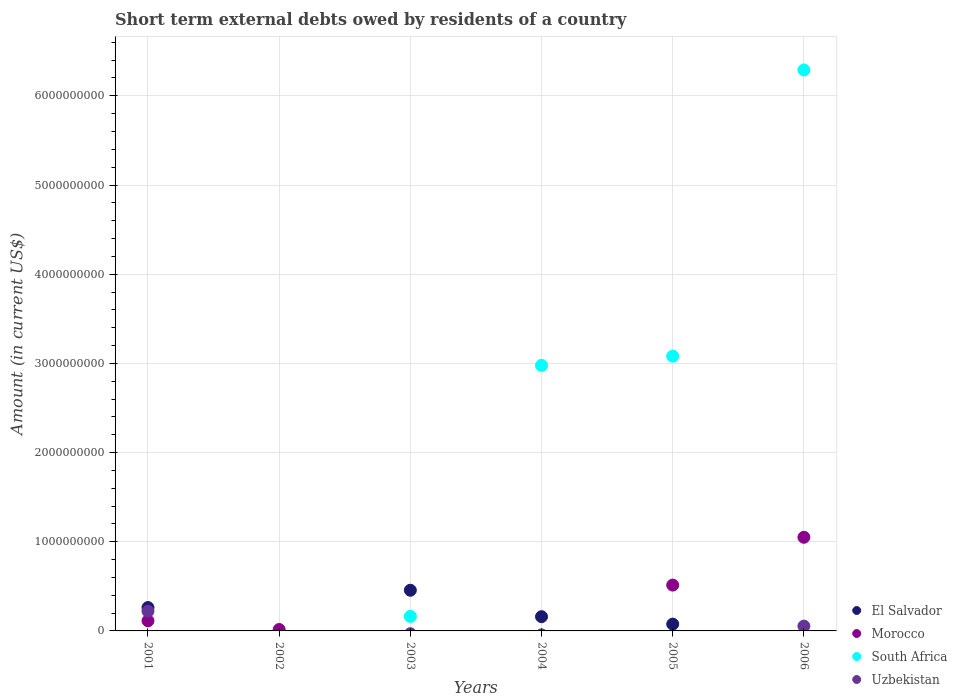How many different coloured dotlines are there?
Provide a succinct answer. 4. What is the amount of short-term external debts owed by residents in Uzbekistan in 2004?
Provide a short and direct response. 0. Across all years, what is the maximum amount of short-term external debts owed by residents in Morocco?
Keep it short and to the point. 1.05e+09. In which year was the amount of short-term external debts owed by residents in Uzbekistan maximum?
Ensure brevity in your answer.  2001. What is the total amount of short-term external debts owed by residents in Morocco in the graph?
Offer a terse response. 1.69e+09. What is the difference between the amount of short-term external debts owed by residents in Morocco in 2002 and that in 2006?
Give a very brief answer. -1.03e+09. What is the difference between the amount of short-term external debts owed by residents in Uzbekistan in 2006 and the amount of short-term external debts owed by residents in Morocco in 2004?
Ensure brevity in your answer.  5.40e+07. What is the average amount of short-term external debts owed by residents in El Salvador per year?
Give a very brief answer. 1.59e+08. In the year 2006, what is the difference between the amount of short-term external debts owed by residents in Morocco and amount of short-term external debts owed by residents in Uzbekistan?
Offer a very short reply. 9.96e+08. In how many years, is the amount of short-term external debts owed by residents in Morocco greater than 6400000000 US$?
Give a very brief answer. 0. What is the ratio of the amount of short-term external debts owed by residents in Morocco in 2002 to that in 2005?
Offer a very short reply. 0.03. Is the amount of short-term external debts owed by residents in Morocco in 2002 less than that in 2006?
Make the answer very short. Yes. What is the difference between the highest and the second highest amount of short-term external debts owed by residents in South Africa?
Give a very brief answer. 3.21e+09. What is the difference between the highest and the lowest amount of short-term external debts owed by residents in Morocco?
Give a very brief answer. 1.05e+09. In how many years, is the amount of short-term external debts owed by residents in South Africa greater than the average amount of short-term external debts owed by residents in South Africa taken over all years?
Provide a succinct answer. 3. Does the amount of short-term external debts owed by residents in El Salvador monotonically increase over the years?
Provide a short and direct response. No. Is the amount of short-term external debts owed by residents in Morocco strictly greater than the amount of short-term external debts owed by residents in El Salvador over the years?
Offer a very short reply. No. Is the amount of short-term external debts owed by residents in Uzbekistan strictly less than the amount of short-term external debts owed by residents in Morocco over the years?
Give a very brief answer. No. How many years are there in the graph?
Provide a succinct answer. 6. What is the difference between two consecutive major ticks on the Y-axis?
Offer a terse response. 1.00e+09. Does the graph contain any zero values?
Keep it short and to the point. Yes. Where does the legend appear in the graph?
Offer a terse response. Bottom right. How are the legend labels stacked?
Keep it short and to the point. Vertical. What is the title of the graph?
Your response must be concise. Short term external debts owed by residents of a country. What is the label or title of the X-axis?
Your answer should be very brief. Years. What is the Amount (in current US$) of El Salvador in 2001?
Make the answer very short. 2.62e+08. What is the Amount (in current US$) of Morocco in 2001?
Offer a terse response. 1.14e+08. What is the Amount (in current US$) of South Africa in 2001?
Give a very brief answer. 0. What is the Amount (in current US$) of Uzbekistan in 2001?
Keep it short and to the point. 2.21e+08. What is the Amount (in current US$) of Morocco in 2002?
Keep it short and to the point. 1.60e+07. What is the Amount (in current US$) in South Africa in 2002?
Ensure brevity in your answer.  0. What is the Amount (in current US$) in Uzbekistan in 2002?
Offer a very short reply. 0. What is the Amount (in current US$) of El Salvador in 2003?
Make the answer very short. 4.56e+08. What is the Amount (in current US$) of Morocco in 2003?
Your answer should be compact. 0. What is the Amount (in current US$) in South Africa in 2003?
Make the answer very short. 1.63e+08. What is the Amount (in current US$) in Uzbekistan in 2003?
Your answer should be compact. 0. What is the Amount (in current US$) of El Salvador in 2004?
Your response must be concise. 1.60e+08. What is the Amount (in current US$) of South Africa in 2004?
Your response must be concise. 2.98e+09. What is the Amount (in current US$) of Uzbekistan in 2004?
Offer a terse response. 0. What is the Amount (in current US$) in El Salvador in 2005?
Provide a succinct answer. 7.65e+07. What is the Amount (in current US$) in Morocco in 2005?
Offer a terse response. 5.14e+08. What is the Amount (in current US$) of South Africa in 2005?
Offer a very short reply. 3.08e+09. What is the Amount (in current US$) of Uzbekistan in 2005?
Provide a short and direct response. 0. What is the Amount (in current US$) of El Salvador in 2006?
Your response must be concise. 0. What is the Amount (in current US$) of Morocco in 2006?
Offer a terse response. 1.05e+09. What is the Amount (in current US$) of South Africa in 2006?
Your response must be concise. 6.29e+09. What is the Amount (in current US$) of Uzbekistan in 2006?
Provide a succinct answer. 5.40e+07. Across all years, what is the maximum Amount (in current US$) in El Salvador?
Provide a short and direct response. 4.56e+08. Across all years, what is the maximum Amount (in current US$) of Morocco?
Offer a terse response. 1.05e+09. Across all years, what is the maximum Amount (in current US$) in South Africa?
Give a very brief answer. 6.29e+09. Across all years, what is the maximum Amount (in current US$) of Uzbekistan?
Ensure brevity in your answer.  2.21e+08. Across all years, what is the minimum Amount (in current US$) in Uzbekistan?
Keep it short and to the point. 0. What is the total Amount (in current US$) of El Salvador in the graph?
Your answer should be very brief. 9.54e+08. What is the total Amount (in current US$) of Morocco in the graph?
Provide a short and direct response. 1.69e+09. What is the total Amount (in current US$) of South Africa in the graph?
Provide a short and direct response. 1.25e+1. What is the total Amount (in current US$) of Uzbekistan in the graph?
Give a very brief answer. 2.75e+08. What is the difference between the Amount (in current US$) of Morocco in 2001 and that in 2002?
Make the answer very short. 9.80e+07. What is the difference between the Amount (in current US$) in El Salvador in 2001 and that in 2003?
Keep it short and to the point. -1.94e+08. What is the difference between the Amount (in current US$) of El Salvador in 2001 and that in 2004?
Your response must be concise. 1.02e+08. What is the difference between the Amount (in current US$) of El Salvador in 2001 and that in 2005?
Offer a terse response. 1.85e+08. What is the difference between the Amount (in current US$) in Morocco in 2001 and that in 2005?
Offer a very short reply. -4.00e+08. What is the difference between the Amount (in current US$) of Morocco in 2001 and that in 2006?
Make the answer very short. -9.36e+08. What is the difference between the Amount (in current US$) in Uzbekistan in 2001 and that in 2006?
Provide a short and direct response. 1.67e+08. What is the difference between the Amount (in current US$) in Morocco in 2002 and that in 2005?
Your answer should be very brief. -4.98e+08. What is the difference between the Amount (in current US$) of Morocco in 2002 and that in 2006?
Your response must be concise. -1.03e+09. What is the difference between the Amount (in current US$) of El Salvador in 2003 and that in 2004?
Offer a terse response. 2.96e+08. What is the difference between the Amount (in current US$) of South Africa in 2003 and that in 2004?
Offer a very short reply. -2.82e+09. What is the difference between the Amount (in current US$) in El Salvador in 2003 and that in 2005?
Make the answer very short. 3.79e+08. What is the difference between the Amount (in current US$) of South Africa in 2003 and that in 2005?
Your answer should be very brief. -2.92e+09. What is the difference between the Amount (in current US$) of South Africa in 2003 and that in 2006?
Provide a short and direct response. -6.13e+09. What is the difference between the Amount (in current US$) in El Salvador in 2004 and that in 2005?
Provide a short and direct response. 8.33e+07. What is the difference between the Amount (in current US$) of South Africa in 2004 and that in 2005?
Your answer should be compact. -1.03e+08. What is the difference between the Amount (in current US$) of South Africa in 2004 and that in 2006?
Offer a very short reply. -3.31e+09. What is the difference between the Amount (in current US$) of Morocco in 2005 and that in 2006?
Provide a short and direct response. -5.36e+08. What is the difference between the Amount (in current US$) of South Africa in 2005 and that in 2006?
Make the answer very short. -3.21e+09. What is the difference between the Amount (in current US$) in El Salvador in 2001 and the Amount (in current US$) in Morocco in 2002?
Give a very brief answer. 2.46e+08. What is the difference between the Amount (in current US$) in El Salvador in 2001 and the Amount (in current US$) in South Africa in 2003?
Your answer should be very brief. 9.90e+07. What is the difference between the Amount (in current US$) of Morocco in 2001 and the Amount (in current US$) of South Africa in 2003?
Your answer should be very brief. -4.90e+07. What is the difference between the Amount (in current US$) in El Salvador in 2001 and the Amount (in current US$) in South Africa in 2004?
Provide a short and direct response. -2.72e+09. What is the difference between the Amount (in current US$) of Morocco in 2001 and the Amount (in current US$) of South Africa in 2004?
Ensure brevity in your answer.  -2.86e+09. What is the difference between the Amount (in current US$) in El Salvador in 2001 and the Amount (in current US$) in Morocco in 2005?
Your answer should be very brief. -2.52e+08. What is the difference between the Amount (in current US$) of El Salvador in 2001 and the Amount (in current US$) of South Africa in 2005?
Keep it short and to the point. -2.82e+09. What is the difference between the Amount (in current US$) of Morocco in 2001 and the Amount (in current US$) of South Africa in 2005?
Provide a short and direct response. -2.97e+09. What is the difference between the Amount (in current US$) in El Salvador in 2001 and the Amount (in current US$) in Morocco in 2006?
Offer a terse response. -7.88e+08. What is the difference between the Amount (in current US$) in El Salvador in 2001 and the Amount (in current US$) in South Africa in 2006?
Keep it short and to the point. -6.03e+09. What is the difference between the Amount (in current US$) of El Salvador in 2001 and the Amount (in current US$) of Uzbekistan in 2006?
Give a very brief answer. 2.08e+08. What is the difference between the Amount (in current US$) of Morocco in 2001 and the Amount (in current US$) of South Africa in 2006?
Give a very brief answer. -6.18e+09. What is the difference between the Amount (in current US$) of Morocco in 2001 and the Amount (in current US$) of Uzbekistan in 2006?
Your answer should be compact. 6.00e+07. What is the difference between the Amount (in current US$) of Morocco in 2002 and the Amount (in current US$) of South Africa in 2003?
Make the answer very short. -1.47e+08. What is the difference between the Amount (in current US$) of Morocco in 2002 and the Amount (in current US$) of South Africa in 2004?
Your answer should be very brief. -2.96e+09. What is the difference between the Amount (in current US$) of Morocco in 2002 and the Amount (in current US$) of South Africa in 2005?
Make the answer very short. -3.06e+09. What is the difference between the Amount (in current US$) in Morocco in 2002 and the Amount (in current US$) in South Africa in 2006?
Give a very brief answer. -6.27e+09. What is the difference between the Amount (in current US$) in Morocco in 2002 and the Amount (in current US$) in Uzbekistan in 2006?
Offer a very short reply. -3.80e+07. What is the difference between the Amount (in current US$) of El Salvador in 2003 and the Amount (in current US$) of South Africa in 2004?
Your answer should be very brief. -2.52e+09. What is the difference between the Amount (in current US$) of El Salvador in 2003 and the Amount (in current US$) of Morocco in 2005?
Offer a terse response. -5.80e+07. What is the difference between the Amount (in current US$) in El Salvador in 2003 and the Amount (in current US$) in South Africa in 2005?
Ensure brevity in your answer.  -2.62e+09. What is the difference between the Amount (in current US$) of El Salvador in 2003 and the Amount (in current US$) of Morocco in 2006?
Provide a short and direct response. -5.94e+08. What is the difference between the Amount (in current US$) of El Salvador in 2003 and the Amount (in current US$) of South Africa in 2006?
Ensure brevity in your answer.  -5.83e+09. What is the difference between the Amount (in current US$) in El Salvador in 2003 and the Amount (in current US$) in Uzbekistan in 2006?
Your answer should be compact. 4.02e+08. What is the difference between the Amount (in current US$) of South Africa in 2003 and the Amount (in current US$) of Uzbekistan in 2006?
Provide a short and direct response. 1.09e+08. What is the difference between the Amount (in current US$) in El Salvador in 2004 and the Amount (in current US$) in Morocco in 2005?
Offer a very short reply. -3.54e+08. What is the difference between the Amount (in current US$) in El Salvador in 2004 and the Amount (in current US$) in South Africa in 2005?
Your answer should be very brief. -2.92e+09. What is the difference between the Amount (in current US$) of El Salvador in 2004 and the Amount (in current US$) of Morocco in 2006?
Keep it short and to the point. -8.90e+08. What is the difference between the Amount (in current US$) of El Salvador in 2004 and the Amount (in current US$) of South Africa in 2006?
Your answer should be very brief. -6.13e+09. What is the difference between the Amount (in current US$) in El Salvador in 2004 and the Amount (in current US$) in Uzbekistan in 2006?
Offer a terse response. 1.06e+08. What is the difference between the Amount (in current US$) of South Africa in 2004 and the Amount (in current US$) of Uzbekistan in 2006?
Your response must be concise. 2.92e+09. What is the difference between the Amount (in current US$) of El Salvador in 2005 and the Amount (in current US$) of Morocco in 2006?
Keep it short and to the point. -9.73e+08. What is the difference between the Amount (in current US$) of El Salvador in 2005 and the Amount (in current US$) of South Africa in 2006?
Offer a very short reply. -6.21e+09. What is the difference between the Amount (in current US$) in El Salvador in 2005 and the Amount (in current US$) in Uzbekistan in 2006?
Offer a very short reply. 2.25e+07. What is the difference between the Amount (in current US$) of Morocco in 2005 and the Amount (in current US$) of South Africa in 2006?
Provide a short and direct response. -5.78e+09. What is the difference between the Amount (in current US$) of Morocco in 2005 and the Amount (in current US$) of Uzbekistan in 2006?
Give a very brief answer. 4.60e+08. What is the difference between the Amount (in current US$) in South Africa in 2005 and the Amount (in current US$) in Uzbekistan in 2006?
Give a very brief answer. 3.03e+09. What is the average Amount (in current US$) in El Salvador per year?
Offer a very short reply. 1.59e+08. What is the average Amount (in current US$) of Morocco per year?
Offer a very short reply. 2.82e+08. What is the average Amount (in current US$) of South Africa per year?
Provide a short and direct response. 2.09e+09. What is the average Amount (in current US$) of Uzbekistan per year?
Make the answer very short. 4.58e+07. In the year 2001, what is the difference between the Amount (in current US$) of El Salvador and Amount (in current US$) of Morocco?
Provide a short and direct response. 1.48e+08. In the year 2001, what is the difference between the Amount (in current US$) in El Salvador and Amount (in current US$) in Uzbekistan?
Provide a succinct answer. 4.15e+07. In the year 2001, what is the difference between the Amount (in current US$) in Morocco and Amount (in current US$) in Uzbekistan?
Keep it short and to the point. -1.07e+08. In the year 2003, what is the difference between the Amount (in current US$) in El Salvador and Amount (in current US$) in South Africa?
Keep it short and to the point. 2.93e+08. In the year 2004, what is the difference between the Amount (in current US$) in El Salvador and Amount (in current US$) in South Africa?
Keep it short and to the point. -2.82e+09. In the year 2005, what is the difference between the Amount (in current US$) of El Salvador and Amount (in current US$) of Morocco?
Make the answer very short. -4.37e+08. In the year 2005, what is the difference between the Amount (in current US$) in El Salvador and Amount (in current US$) in South Africa?
Give a very brief answer. -3.00e+09. In the year 2005, what is the difference between the Amount (in current US$) in Morocco and Amount (in current US$) in South Africa?
Your answer should be compact. -2.57e+09. In the year 2006, what is the difference between the Amount (in current US$) of Morocco and Amount (in current US$) of South Africa?
Ensure brevity in your answer.  -5.24e+09. In the year 2006, what is the difference between the Amount (in current US$) in Morocco and Amount (in current US$) in Uzbekistan?
Offer a very short reply. 9.96e+08. In the year 2006, what is the difference between the Amount (in current US$) in South Africa and Amount (in current US$) in Uzbekistan?
Give a very brief answer. 6.24e+09. What is the ratio of the Amount (in current US$) of Morocco in 2001 to that in 2002?
Make the answer very short. 7.12. What is the ratio of the Amount (in current US$) in El Salvador in 2001 to that in 2003?
Provide a succinct answer. 0.57. What is the ratio of the Amount (in current US$) in El Salvador in 2001 to that in 2004?
Make the answer very short. 1.64. What is the ratio of the Amount (in current US$) in El Salvador in 2001 to that in 2005?
Make the answer very short. 3.42. What is the ratio of the Amount (in current US$) of Morocco in 2001 to that in 2005?
Your response must be concise. 0.22. What is the ratio of the Amount (in current US$) in Morocco in 2001 to that in 2006?
Provide a short and direct response. 0.11. What is the ratio of the Amount (in current US$) of Uzbekistan in 2001 to that in 2006?
Provide a short and direct response. 4.08. What is the ratio of the Amount (in current US$) in Morocco in 2002 to that in 2005?
Make the answer very short. 0.03. What is the ratio of the Amount (in current US$) in Morocco in 2002 to that in 2006?
Offer a very short reply. 0.02. What is the ratio of the Amount (in current US$) in El Salvador in 2003 to that in 2004?
Provide a succinct answer. 2.85. What is the ratio of the Amount (in current US$) in South Africa in 2003 to that in 2004?
Your answer should be compact. 0.05. What is the ratio of the Amount (in current US$) of El Salvador in 2003 to that in 2005?
Provide a succinct answer. 5.96. What is the ratio of the Amount (in current US$) in South Africa in 2003 to that in 2005?
Provide a short and direct response. 0.05. What is the ratio of the Amount (in current US$) in South Africa in 2003 to that in 2006?
Offer a very short reply. 0.03. What is the ratio of the Amount (in current US$) of El Salvador in 2004 to that in 2005?
Provide a short and direct response. 2.09. What is the ratio of the Amount (in current US$) in South Africa in 2004 to that in 2005?
Make the answer very short. 0.97. What is the ratio of the Amount (in current US$) of South Africa in 2004 to that in 2006?
Provide a short and direct response. 0.47. What is the ratio of the Amount (in current US$) in Morocco in 2005 to that in 2006?
Your answer should be very brief. 0.49. What is the ratio of the Amount (in current US$) in South Africa in 2005 to that in 2006?
Your answer should be very brief. 0.49. What is the difference between the highest and the second highest Amount (in current US$) of El Salvador?
Offer a very short reply. 1.94e+08. What is the difference between the highest and the second highest Amount (in current US$) in Morocco?
Keep it short and to the point. 5.36e+08. What is the difference between the highest and the second highest Amount (in current US$) in South Africa?
Ensure brevity in your answer.  3.21e+09. What is the difference between the highest and the lowest Amount (in current US$) of El Salvador?
Your answer should be compact. 4.56e+08. What is the difference between the highest and the lowest Amount (in current US$) in Morocco?
Keep it short and to the point. 1.05e+09. What is the difference between the highest and the lowest Amount (in current US$) of South Africa?
Ensure brevity in your answer.  6.29e+09. What is the difference between the highest and the lowest Amount (in current US$) in Uzbekistan?
Provide a short and direct response. 2.21e+08. 